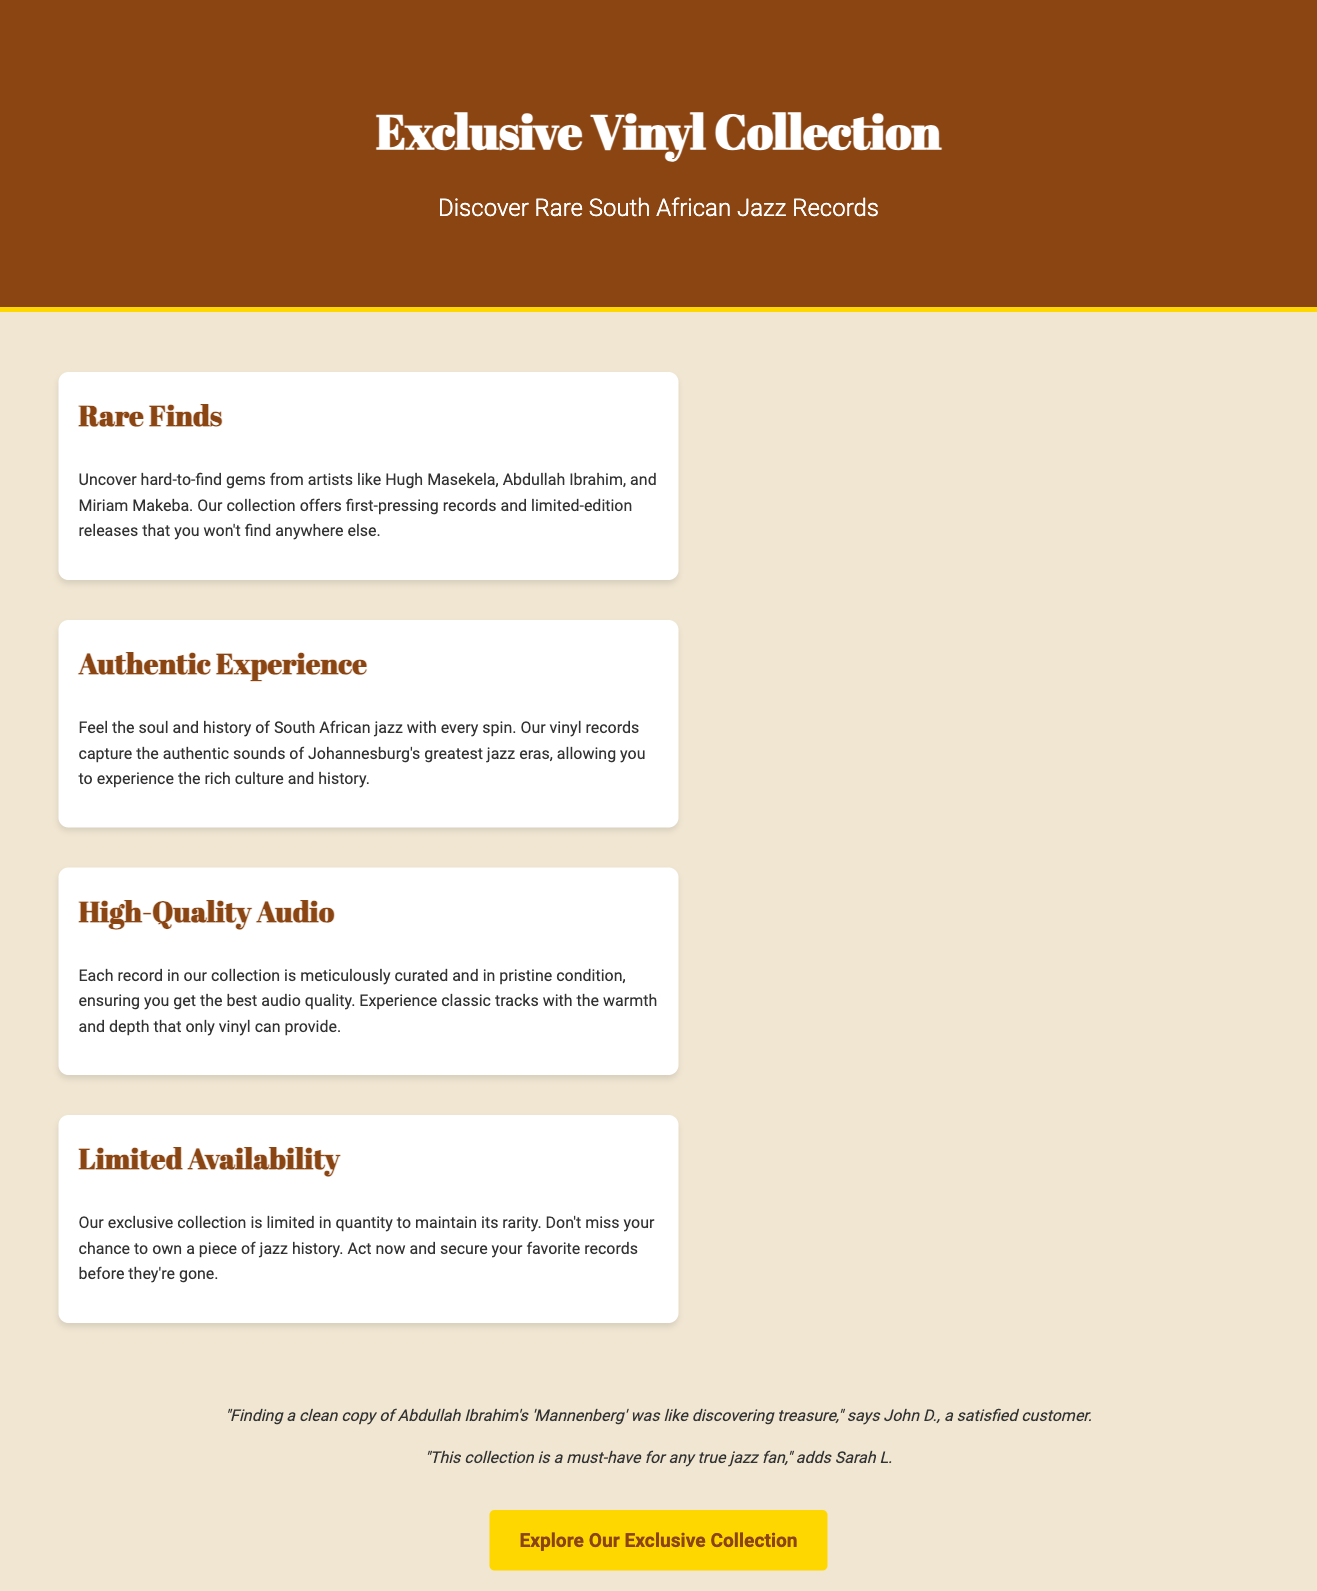What artists are featured in the collection? The document mentions several artists associated with the rare South African jazz records, specifically Hugh Masekela, Abdullah Ibrahim, and Miriam Makeba.
Answer: Hugh Masekela, Abdullah Ibrahim, Miriam Makeba What is the condition of the records in the collection? The advertisement states that each record is “meticulously curated and in pristine condition,” emphasizing their quality and care in selection.
Answer: Pristine condition What does the collection offer that makes it unique? The exclusivity of the collection is highlighted by the mention of "hard-to-find gems" and "limited-edition releases."
Answer: Hard-to-find gems, limited-edition releases What is one customer testimonial about the collection? The testimonials provided include specific praise from customers, like John D. finding Abdullah Ibrahim's "Mannenberg" as a treasure.
Answer: "Finding a clean copy of Abdullah Ibrahim's 'Mannenberg' was like discovering treasure" What should potential customers do to secure records? The document encourages urgency in securing records, suggesting that they should "act now" to avoid missing out on owning these records.
Answer: Act now How many artists are named in the advertisement? The document mentions three specific artists. This counts as the named individuals associated with the collection.
Answer: Three What type of music does this collection focus on? The advertisement clearly indicates that the collection specializes in "South African jazz records," highlighting the genre's focus.
Answer: South African jazz What does "High-Quality Audio" emphasize in the collection? The section describes the audio quality of the records, indicating that listeners will experience “the warmth and depth that only vinyl can provide.”
Answer: Warmth and depth What is the main call to action in the advertisement? The advertisement includes a clear call to action for readers to explore the collection, indicating engagement with potential buyers.
Answer: Explore Our Exclusive Collection 